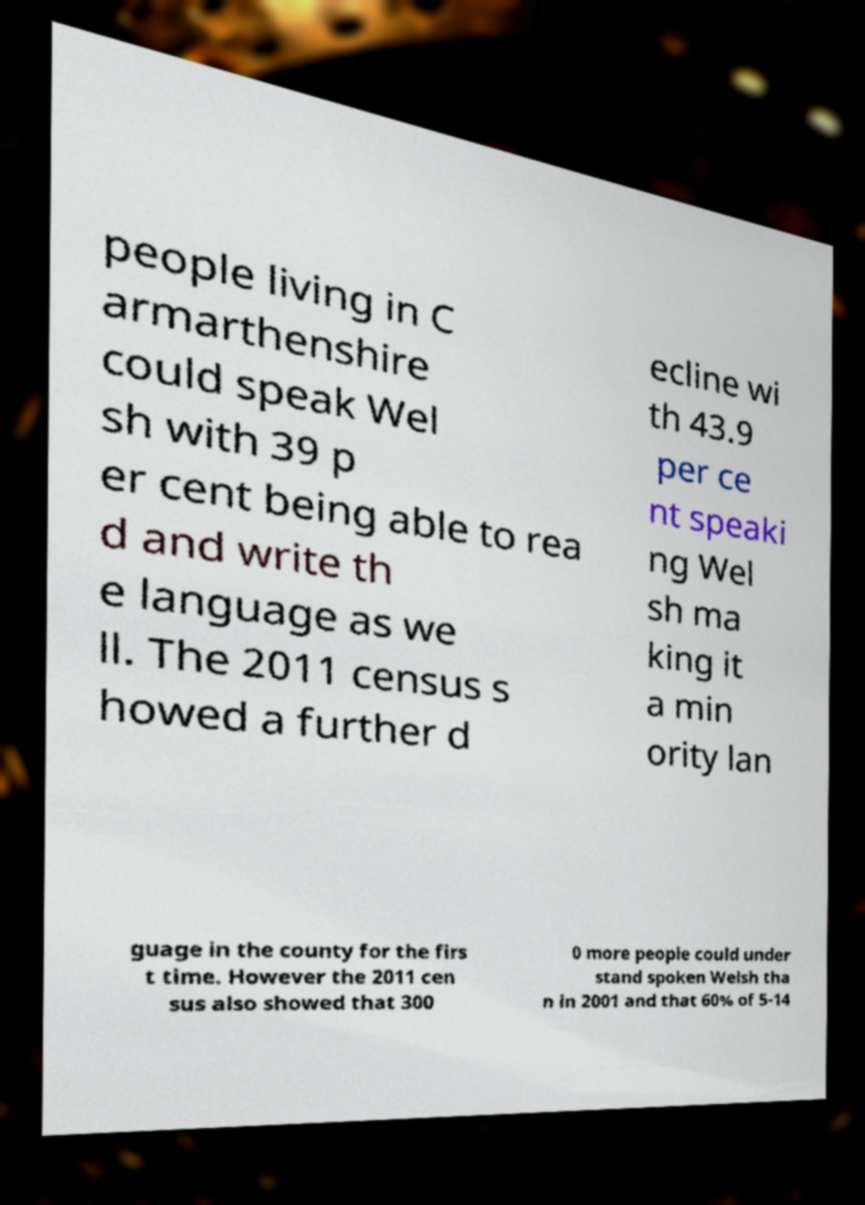Please read and relay the text visible in this image. What does it say? people living in C armarthenshire could speak Wel sh with 39 p er cent being able to rea d and write th e language as we ll. The 2011 census s howed a further d ecline wi th 43.9 per ce nt speaki ng Wel sh ma king it a min ority lan guage in the county for the firs t time. However the 2011 cen sus also showed that 300 0 more people could under stand spoken Welsh tha n in 2001 and that 60% of 5-14 